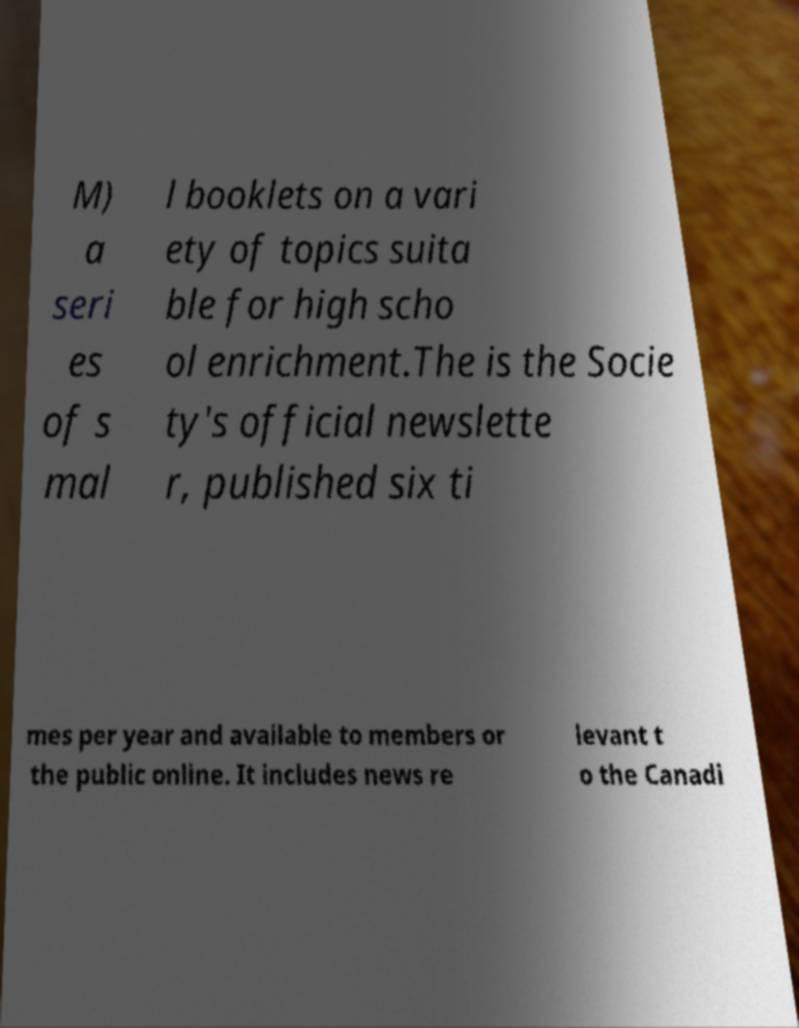What messages or text are displayed in this image? I need them in a readable, typed format. M) a seri es of s mal l booklets on a vari ety of topics suita ble for high scho ol enrichment.The is the Socie ty's official newslette r, published six ti mes per year and available to members or the public online. It includes news re levant t o the Canadi 